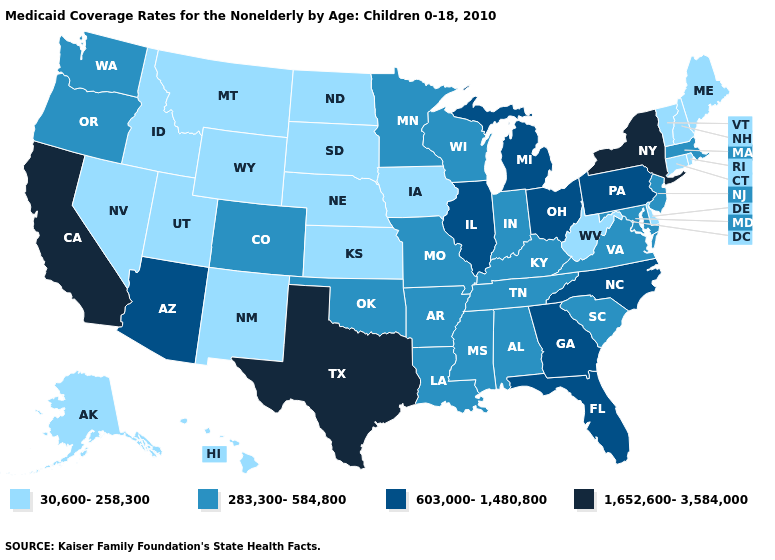What is the lowest value in the Northeast?
Answer briefly. 30,600-258,300. Name the states that have a value in the range 30,600-258,300?
Quick response, please. Alaska, Connecticut, Delaware, Hawaii, Idaho, Iowa, Kansas, Maine, Montana, Nebraska, Nevada, New Hampshire, New Mexico, North Dakota, Rhode Island, South Dakota, Utah, Vermont, West Virginia, Wyoming. Is the legend a continuous bar?
Write a very short answer. No. What is the value of Wyoming?
Be succinct. 30,600-258,300. Name the states that have a value in the range 30,600-258,300?
Concise answer only. Alaska, Connecticut, Delaware, Hawaii, Idaho, Iowa, Kansas, Maine, Montana, Nebraska, Nevada, New Hampshire, New Mexico, North Dakota, Rhode Island, South Dakota, Utah, Vermont, West Virginia, Wyoming. What is the lowest value in states that border Texas?
Keep it brief. 30,600-258,300. Which states have the highest value in the USA?
Keep it brief. California, New York, Texas. Name the states that have a value in the range 603,000-1,480,800?
Answer briefly. Arizona, Florida, Georgia, Illinois, Michigan, North Carolina, Ohio, Pennsylvania. What is the value of Mississippi?
Write a very short answer. 283,300-584,800. Does Connecticut have the highest value in the USA?
Be succinct. No. What is the highest value in the West ?
Give a very brief answer. 1,652,600-3,584,000. Among the states that border North Dakota , which have the lowest value?
Write a very short answer. Montana, South Dakota. What is the value of Louisiana?
Quick response, please. 283,300-584,800. What is the value of South Dakota?
Answer briefly. 30,600-258,300. How many symbols are there in the legend?
Concise answer only. 4. 